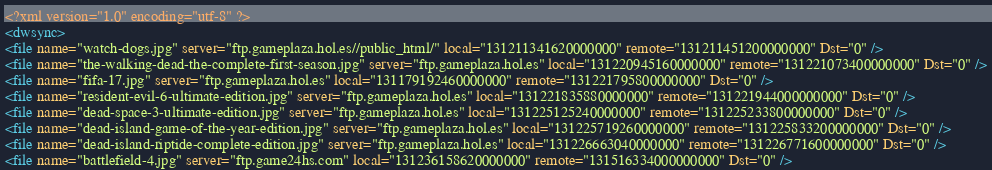<code> <loc_0><loc_0><loc_500><loc_500><_XML_><?xml version="1.0" encoding="utf-8" ?>
<dwsync>
<file name="watch-dogs.jpg" server="ftp.gameplaza.hol.es//public_html/" local="131211341620000000" remote="131211451200000000" Dst="0" />
<file name="the-walking-dead-the-complete-first-season.jpg" server="ftp.gameplaza.hol.es" local="131220945160000000" remote="131221073400000000" Dst="0" />
<file name="fifa-17.jpg" server="ftp.gameplaza.hol.es" local="131179192460000000" remote="131221795800000000" Dst="0" />
<file name="resident-evil-6-ultimate-edition.jpg" server="ftp.gameplaza.hol.es" local="131221835880000000" remote="131221944000000000" Dst="0" />
<file name="dead-space-3-ultimate-edition.jpg" server="ftp.gameplaza.hol.es" local="131225125240000000" remote="131225233800000000" Dst="0" />
<file name="dead-island-game-of-the-year-edition.jpg" server="ftp.gameplaza.hol.es" local="131225719260000000" remote="131225833200000000" Dst="0" />
<file name="dead-island-riptide-complete-edition.jpg" server="ftp.gameplaza.hol.es" local="131226663040000000" remote="131226771600000000" Dst="0" />
<file name="battlefield-4.jpg" server="ftp.game24hs.com" local="131236158620000000" remote="131516334000000000" Dst="0" /></code> 